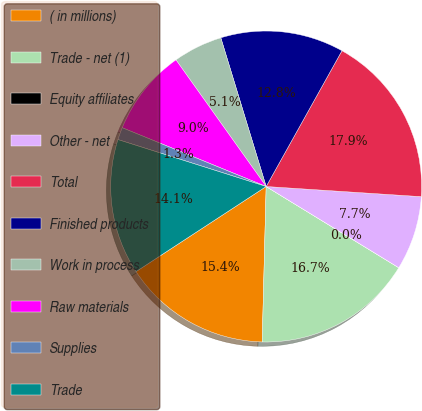<chart> <loc_0><loc_0><loc_500><loc_500><pie_chart><fcel>( in millions)<fcel>Trade - net (1)<fcel>Equity affiliates<fcel>Other - net<fcel>Total<fcel>Finished products<fcel>Work in process<fcel>Raw materials<fcel>Supplies<fcel>Trade<nl><fcel>15.38%<fcel>16.66%<fcel>0.01%<fcel>7.7%<fcel>17.94%<fcel>12.82%<fcel>5.14%<fcel>8.98%<fcel>1.29%<fcel>14.1%<nl></chart> 